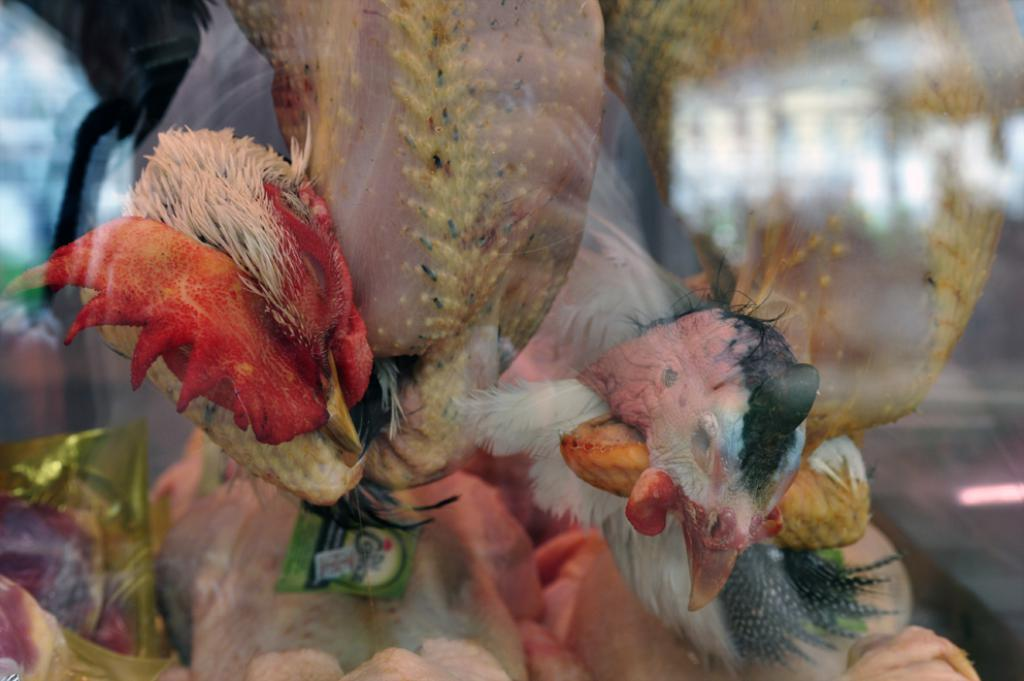What type of animals are present in the image? There are hens in the image. What characteristic is missing from the hens in the image? The hens do not have feathers. What type of noise can be heard coming from the person in the image? There is no person present in the image, only hens. 